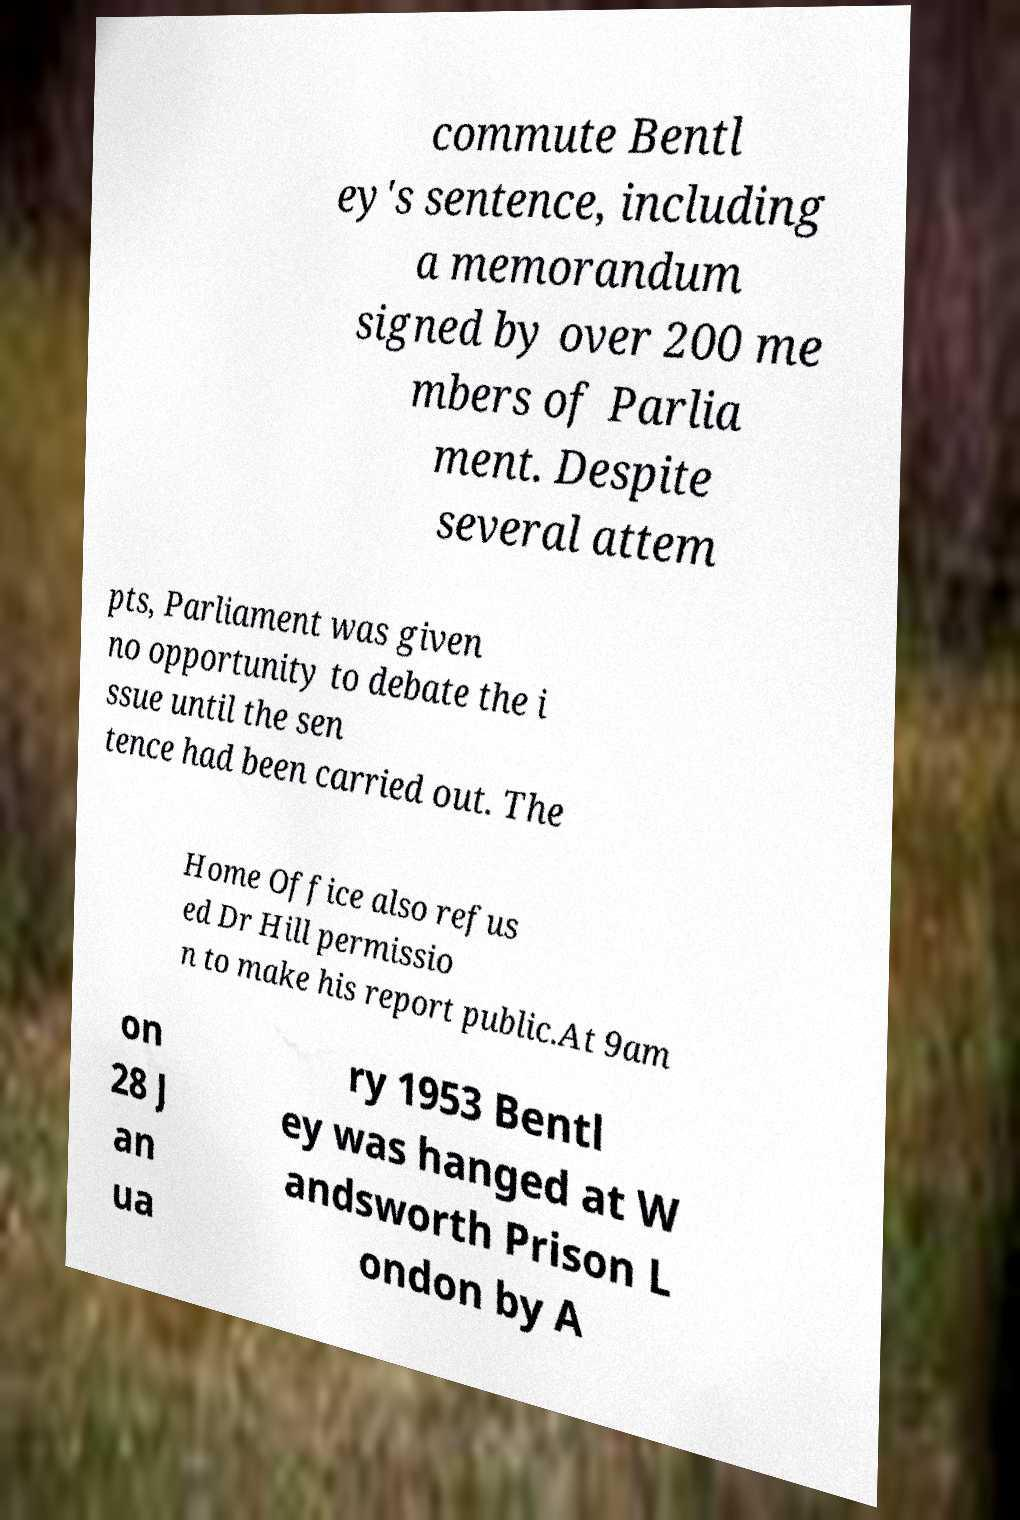Can you read and provide the text displayed in the image?This photo seems to have some interesting text. Can you extract and type it out for me? commute Bentl ey's sentence, including a memorandum signed by over 200 me mbers of Parlia ment. Despite several attem pts, Parliament was given no opportunity to debate the i ssue until the sen tence had been carried out. The Home Office also refus ed Dr Hill permissio n to make his report public.At 9am on 28 J an ua ry 1953 Bentl ey was hanged at W andsworth Prison L ondon by A 